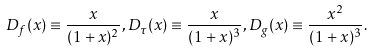Convert formula to latex. <formula><loc_0><loc_0><loc_500><loc_500>D _ { f } ( x ) \equiv \frac { x } { ( 1 + x ) ^ { 2 } } , D _ { \tau } ( x ) \equiv \frac { x } { ( 1 + x ) ^ { 3 } } , D _ { g } ( x ) \equiv \frac { x ^ { 2 } } { ( 1 + x ) ^ { 3 } } .</formula> 